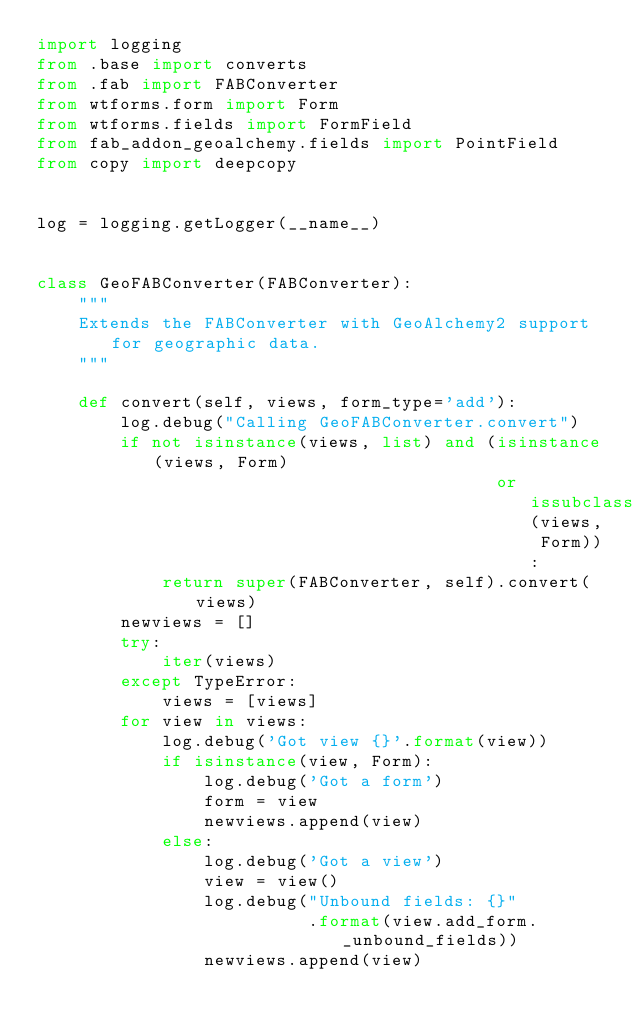Convert code to text. <code><loc_0><loc_0><loc_500><loc_500><_Python_>import logging
from .base import converts
from .fab import FABConverter
from wtforms.form import Form
from wtforms.fields import FormField
from fab_addon_geoalchemy.fields import PointField
from copy import deepcopy


log = logging.getLogger(__name__)


class GeoFABConverter(FABConverter):
    """
    Extends the FABConverter with GeoAlchemy2 support for geographic data.
    """

    def convert(self, views, form_type='add'):
        log.debug("Calling GeoFABConverter.convert")
        if not isinstance(views, list) and (isinstance(views, Form)
                                            or issubclass(views, Form)):
            return super(FABConverter, self).convert(views)
        newviews = []
        try:
            iter(views)
        except TypeError:
            views = [views]
        for view in views:
            log.debug('Got view {}'.format(view))
            if isinstance(view, Form):
                log.debug('Got a form')
                form = view
                newviews.append(view)
            else:
                log.debug('Got a view')
                view = view()
                log.debug("Unbound fields: {}"
                          .format(view.add_form._unbound_fields))
                newviews.append(view)</code> 